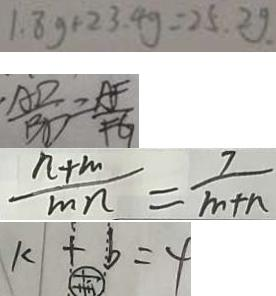Convert formula to latex. <formula><loc_0><loc_0><loc_500><loc_500>1 . 8 g + 2 3 . 4 g = 2 5 . 2 g . 
 \frac { A D } { B D } = \frac { A F } { F G } 
 \frac { n + m } { m n } = \frac { 7 } { m + n } 
 k + b = 4</formula> 